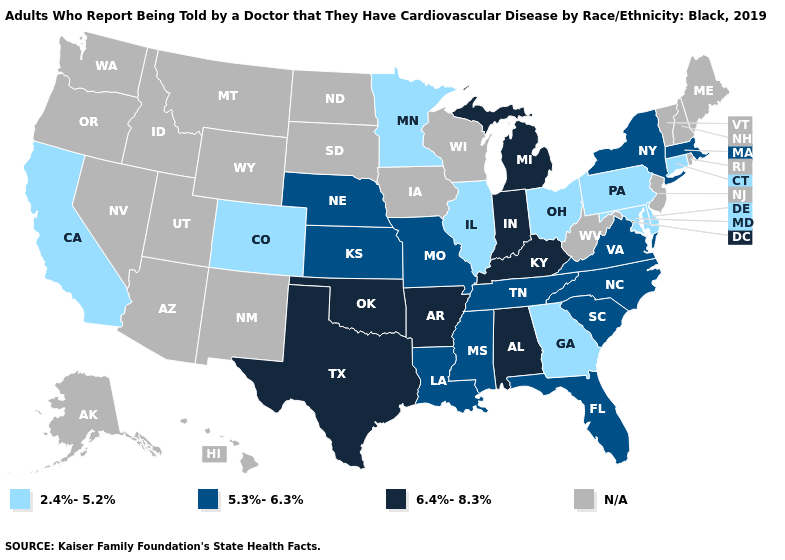Name the states that have a value in the range N/A?
Keep it brief. Alaska, Arizona, Hawaii, Idaho, Iowa, Maine, Montana, Nevada, New Hampshire, New Jersey, New Mexico, North Dakota, Oregon, Rhode Island, South Dakota, Utah, Vermont, Washington, West Virginia, Wisconsin, Wyoming. Which states have the lowest value in the USA?
Keep it brief. California, Colorado, Connecticut, Delaware, Georgia, Illinois, Maryland, Minnesota, Ohio, Pennsylvania. Name the states that have a value in the range 2.4%-5.2%?
Keep it brief. California, Colorado, Connecticut, Delaware, Georgia, Illinois, Maryland, Minnesota, Ohio, Pennsylvania. How many symbols are there in the legend?
Quick response, please. 4. What is the highest value in the Northeast ?
Quick response, please. 5.3%-6.3%. What is the value of South Dakota?
Answer briefly. N/A. Among the states that border West Virginia , does Kentucky have the highest value?
Quick response, please. Yes. What is the value of Illinois?
Keep it brief. 2.4%-5.2%. How many symbols are there in the legend?
Concise answer only. 4. Does Missouri have the highest value in the USA?
Answer briefly. No. Which states have the lowest value in the USA?
Answer briefly. California, Colorado, Connecticut, Delaware, Georgia, Illinois, Maryland, Minnesota, Ohio, Pennsylvania. Name the states that have a value in the range 2.4%-5.2%?
Short answer required. California, Colorado, Connecticut, Delaware, Georgia, Illinois, Maryland, Minnesota, Ohio, Pennsylvania. Name the states that have a value in the range 2.4%-5.2%?
Concise answer only. California, Colorado, Connecticut, Delaware, Georgia, Illinois, Maryland, Minnesota, Ohio, Pennsylvania. Name the states that have a value in the range 2.4%-5.2%?
Concise answer only. California, Colorado, Connecticut, Delaware, Georgia, Illinois, Maryland, Minnesota, Ohio, Pennsylvania. 